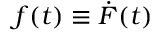<formula> <loc_0><loc_0><loc_500><loc_500>f ( t ) \equiv \dot { F } ( t )</formula> 